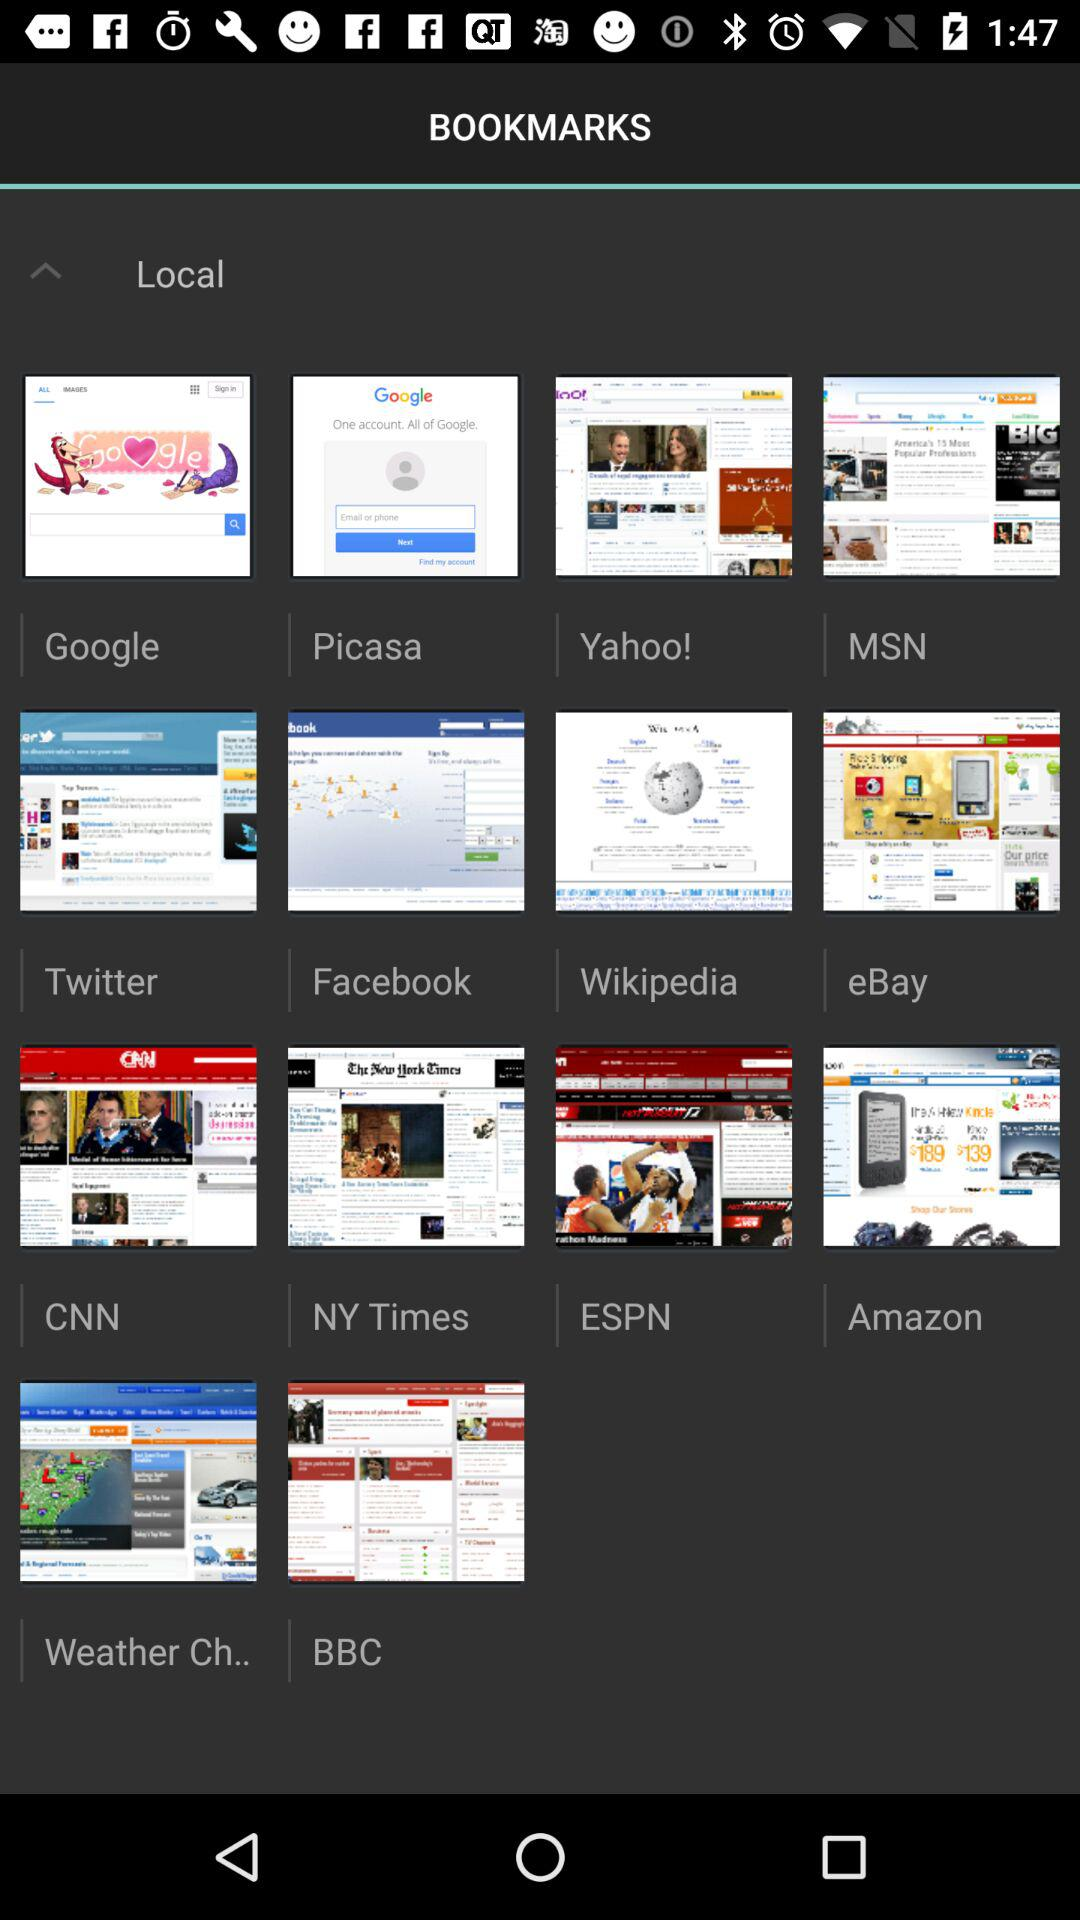Which websites do I have in my bookmarks? The websites you have in your bookmarks are "Google", "Picasa", "Yahoo!", "MSN", "Twitter", "Facebook", "Wikipedia", "eBay", "CNN", "NY Times", "ESPN", "Amazon", "Weather Ch.." and "BBC". 